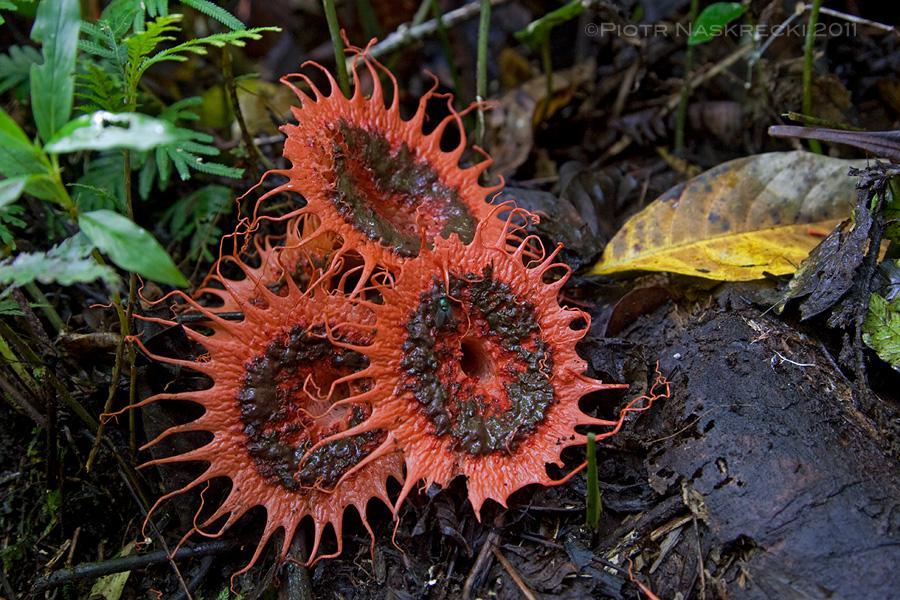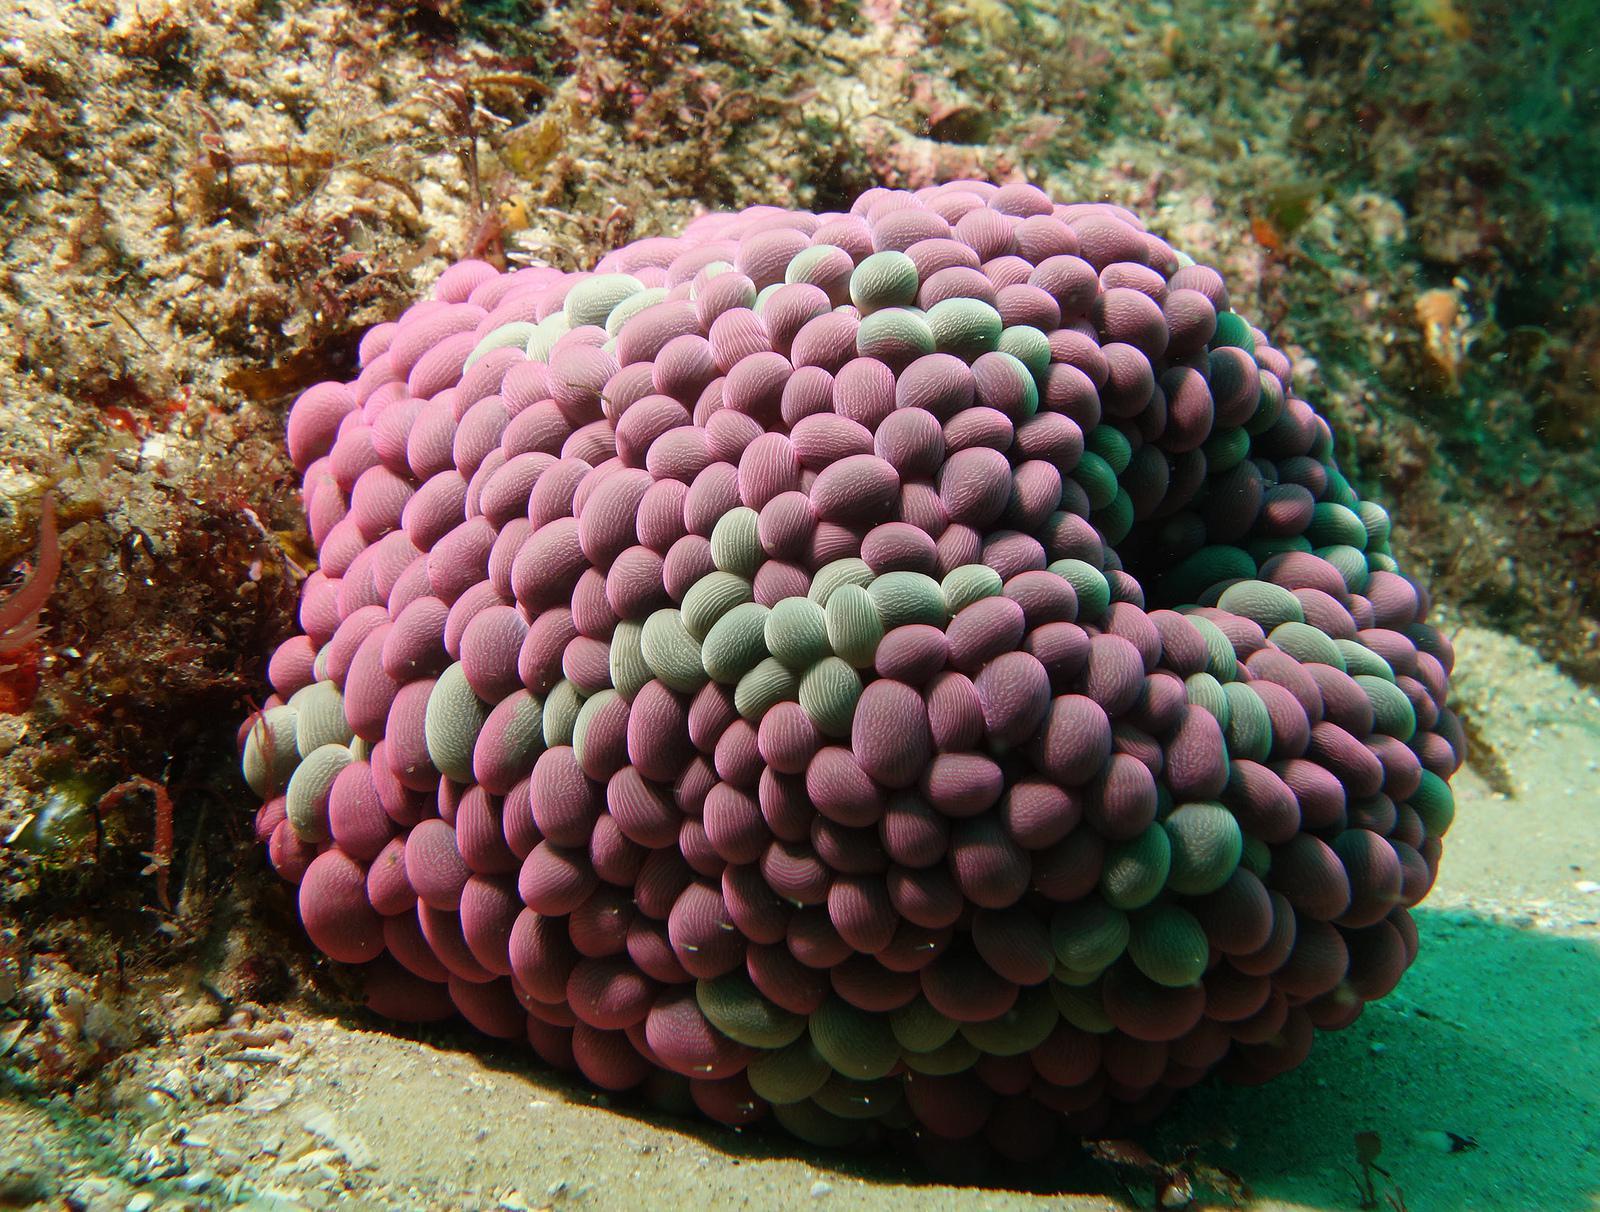The first image is the image on the left, the second image is the image on the right. Assess this claim about the two images: "The right image shows anemone tendrils emerging from a stalk covered with oval shapes.". Correct or not? Answer yes or no. No. 